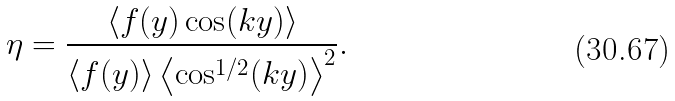Convert formula to latex. <formula><loc_0><loc_0><loc_500><loc_500>\eta = \frac { \left \langle f ( y ) \cos ( k y ) \right \rangle } { \left \langle f ( y ) \right \rangle \left \langle \cos ^ { 1 / 2 } ( k y ) \right \rangle ^ { 2 } } .</formula> 